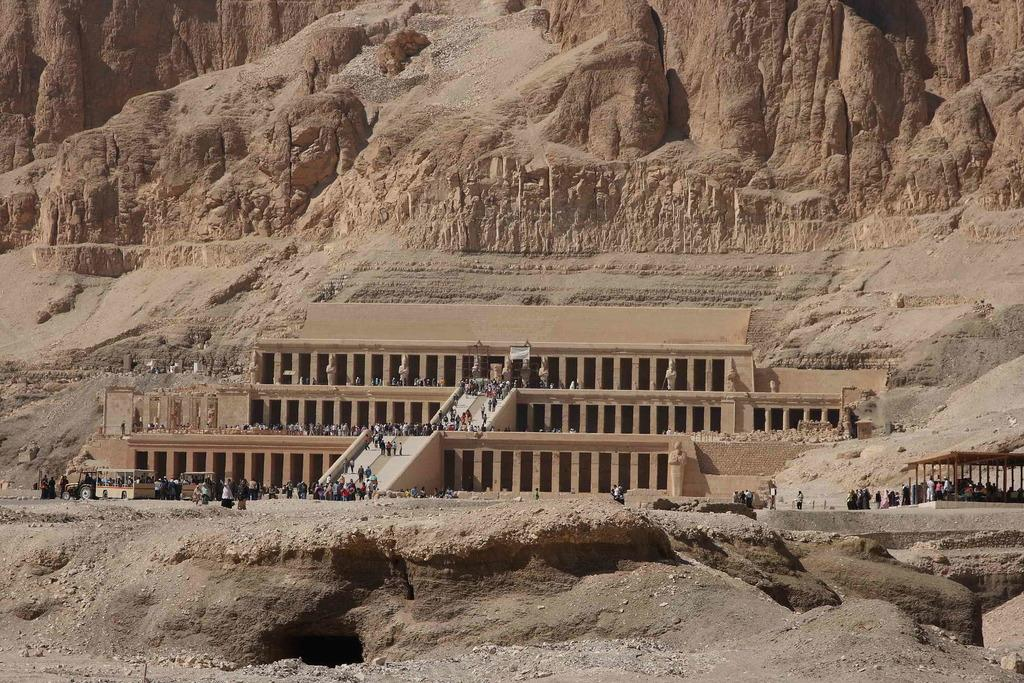What type of landscape feature is present in the image? There is a hill in the image. What type of structure is present in the image? There is a building in the image. What can be seen in front of the building? There are persons and vehicles visible in front of the building. What type of pain is being exchanged between the persons in the image? There is no indication of pain or any exchange of pain in the image. 